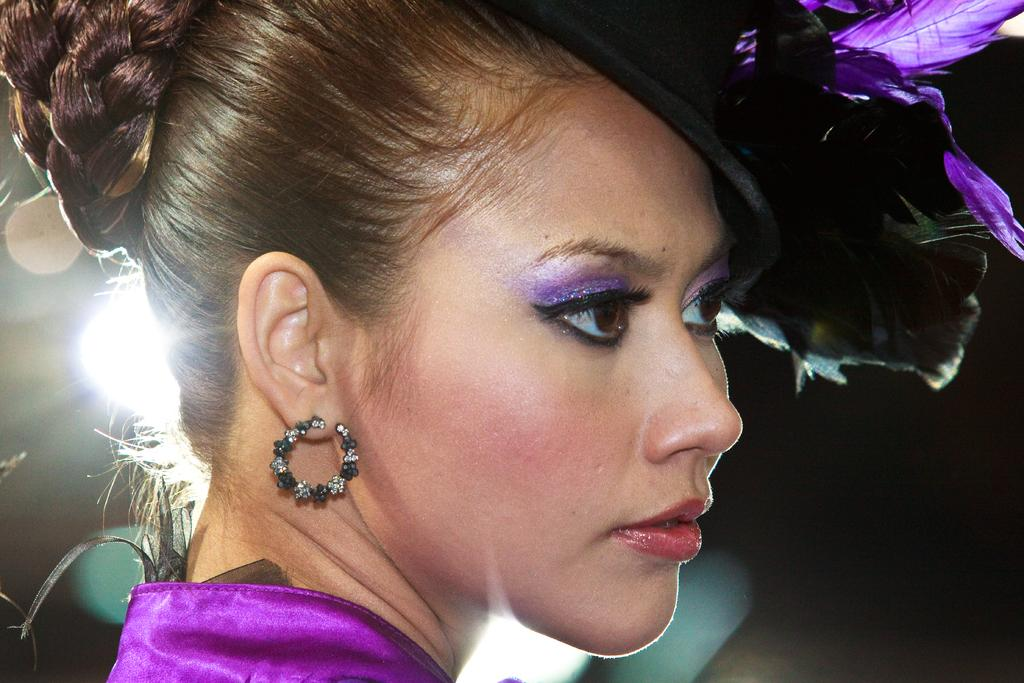Who is the main subject in the image? There is a lady in the image. Can you describe the background of the image? The background of the image is blurred. How many tickets can be seen in the lady's hand in the image? There is no mention of tickets in the image, so it cannot be determined if any are present. 